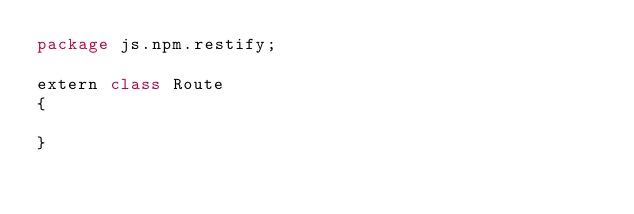<code> <loc_0><loc_0><loc_500><loc_500><_Haxe_>package js.npm.restify;

extern class Route
{

}
</code> 